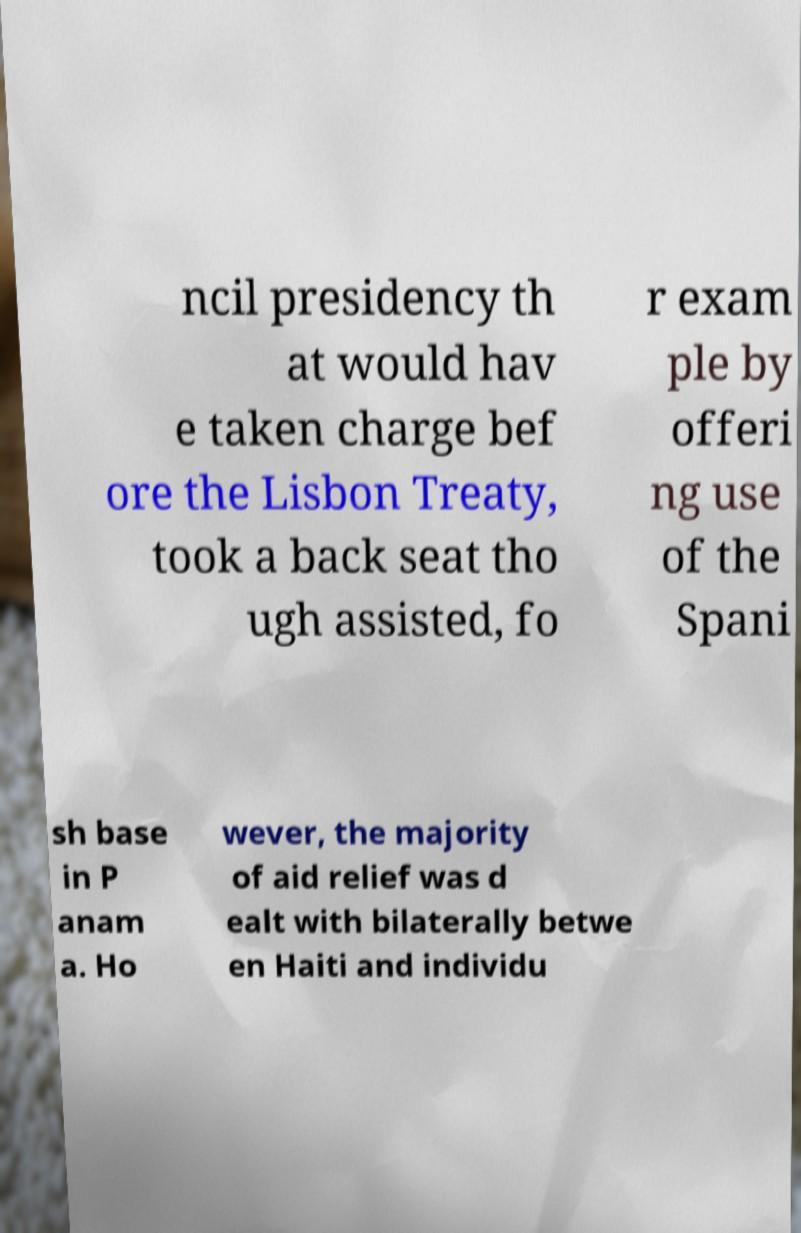I need the written content from this picture converted into text. Can you do that? ncil presidency th at would hav e taken charge bef ore the Lisbon Treaty, took a back seat tho ugh assisted, fo r exam ple by offeri ng use of the Spani sh base in P anam a. Ho wever, the majority of aid relief was d ealt with bilaterally betwe en Haiti and individu 